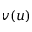Convert formula to latex. <formula><loc_0><loc_0><loc_500><loc_500>v ( u )</formula> 